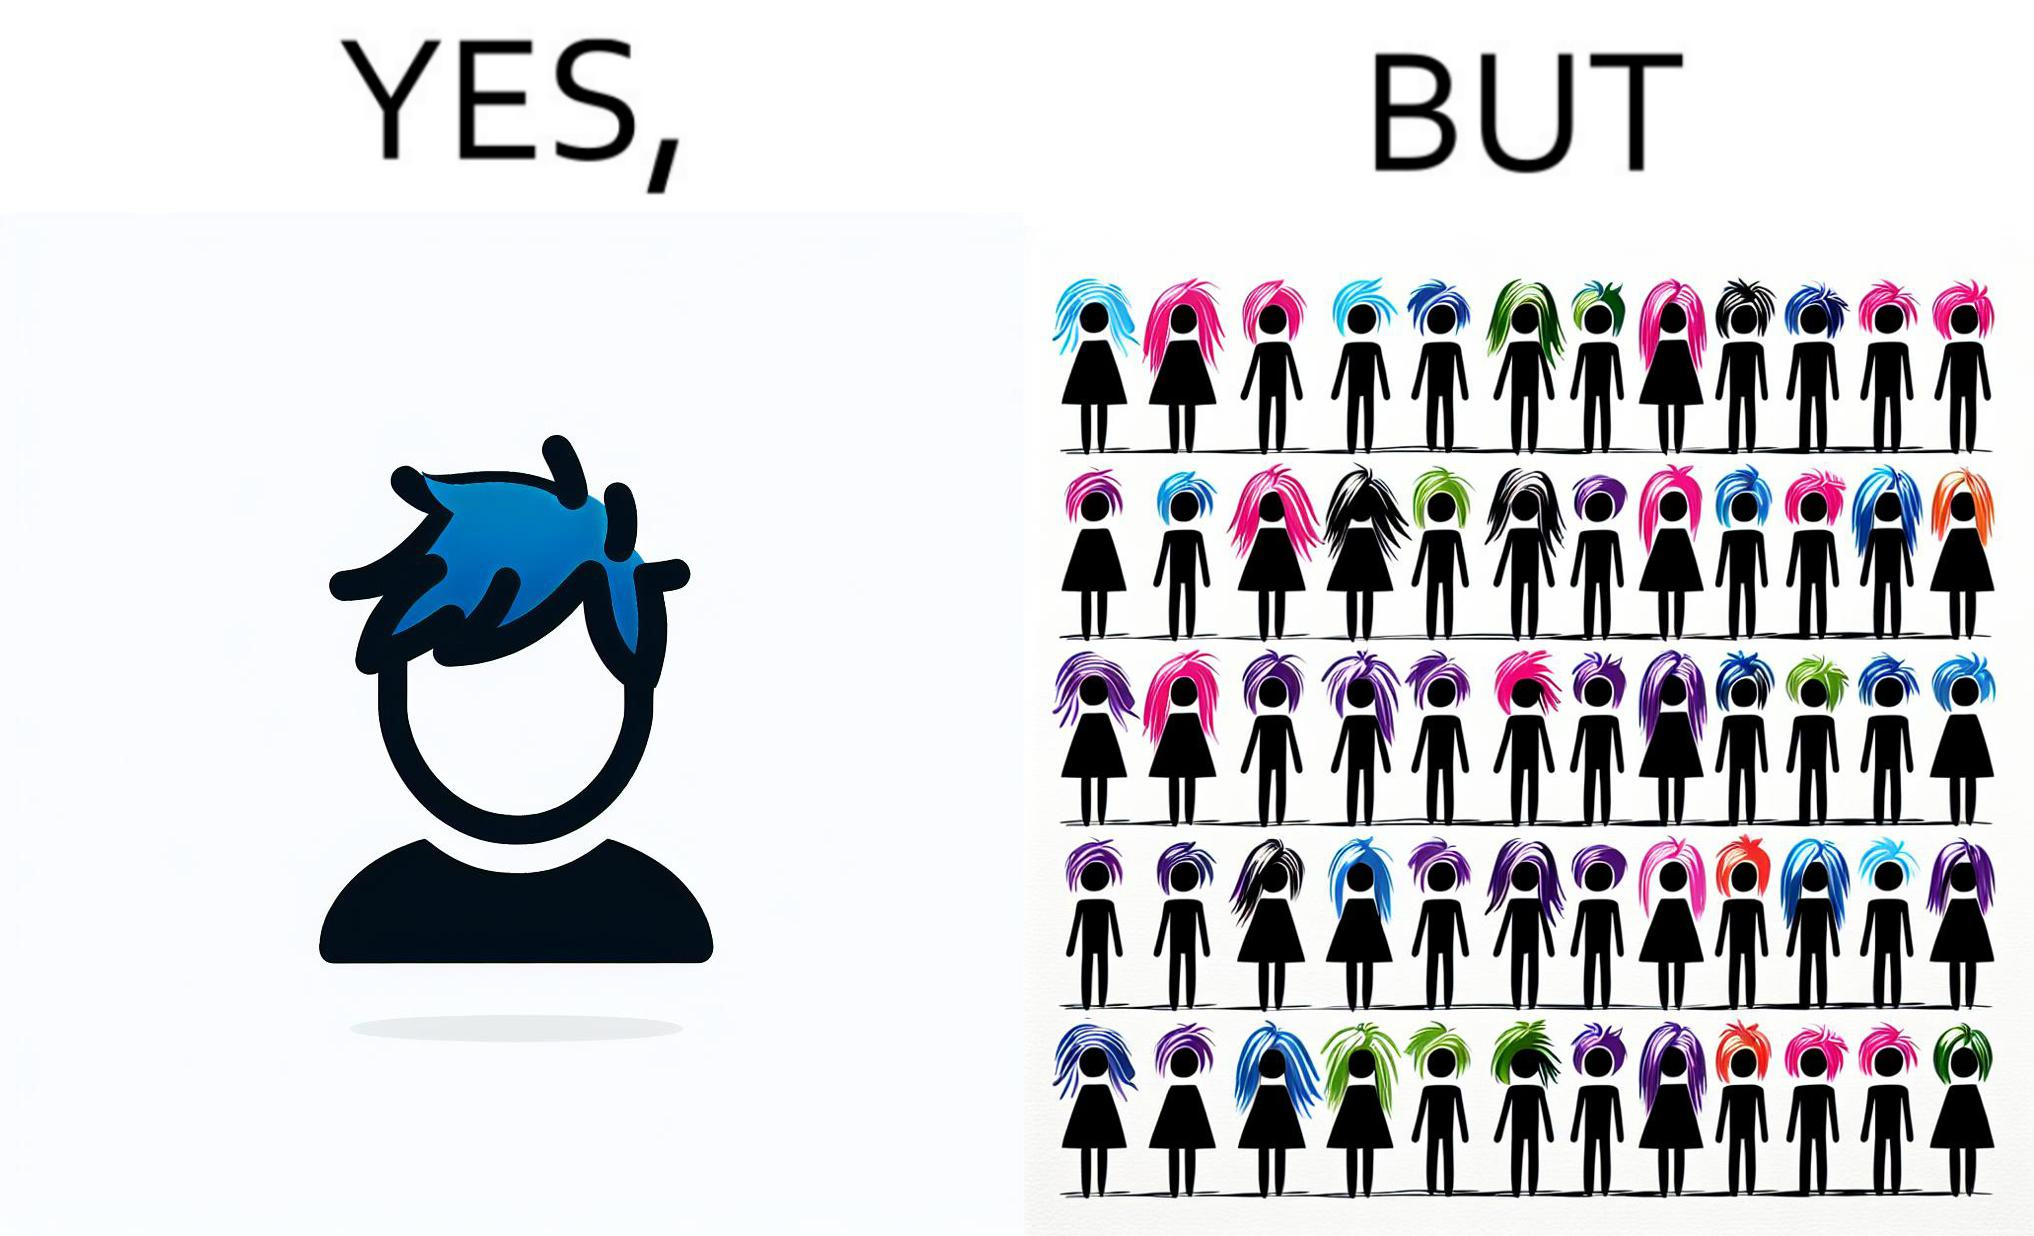What do you see in each half of this image? In the left part of the image: a person with hair dyed blue. In the right part of the image: a group of people having hair dyed in different colors. 